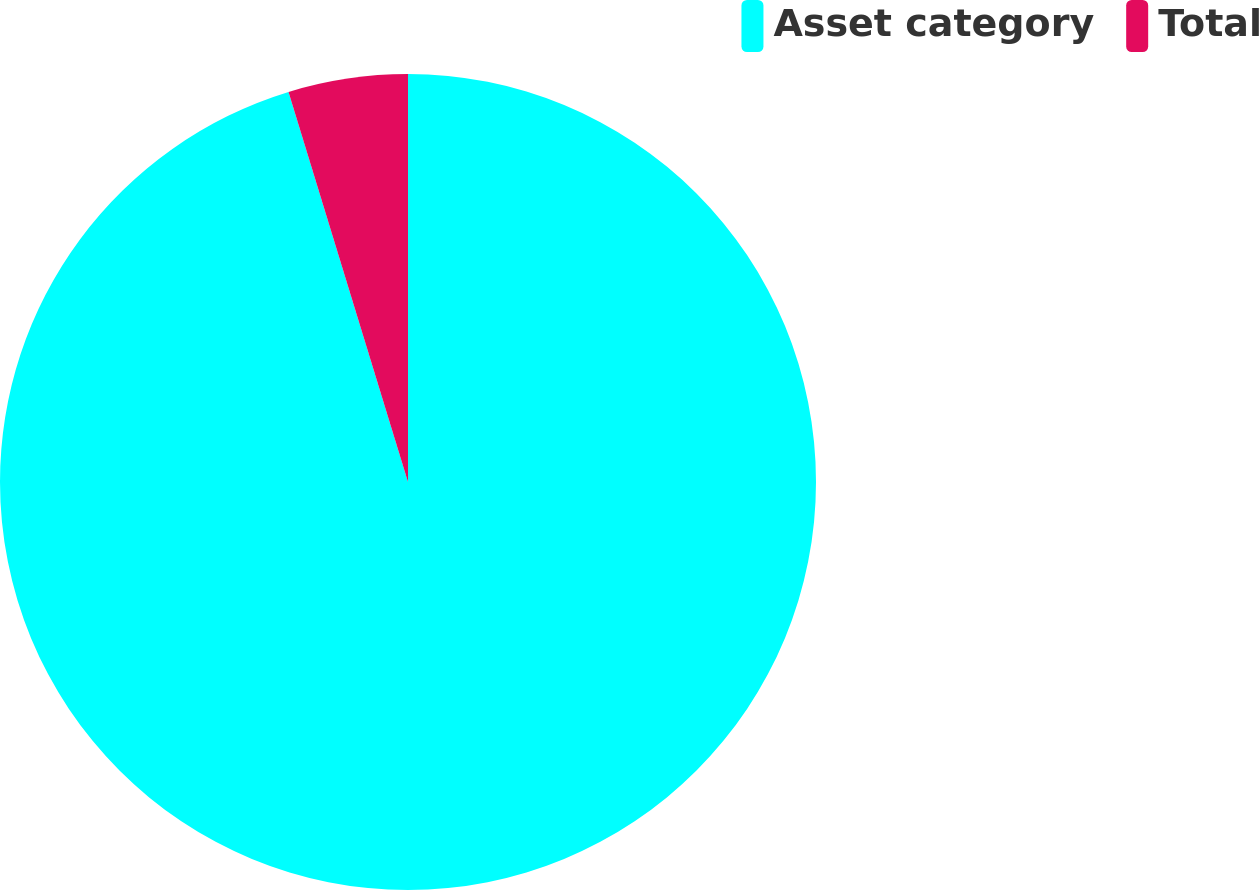Convert chart. <chart><loc_0><loc_0><loc_500><loc_500><pie_chart><fcel>Asset category<fcel>Total<nl><fcel>95.27%<fcel>4.73%<nl></chart> 